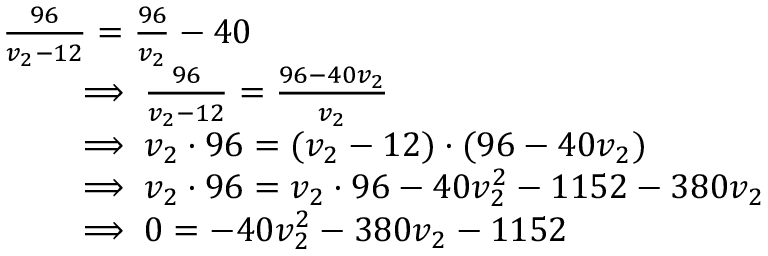Convert formula to latex. <formula><loc_0><loc_0><loc_500><loc_500>\begin{array} { r l } & { \frac { 9 6 } { v _ { 2 } - 1 2 } = \frac { 9 6 } { v _ { 2 } } - 4 0 } \\ & { \quad \implies \frac { 9 6 } { v _ { 2 } - 1 2 } = \frac { 9 6 - 4 0 v _ { 2 } } { v _ { 2 } } } \\ & { \quad \implies v _ { 2 } \cdot 9 6 = ( v _ { 2 } - 1 2 ) \cdot ( 9 6 - 4 0 v _ { 2 } ) } \\ & { \quad \implies v _ { 2 } \cdot 9 6 = v _ { 2 } \cdot 9 6 - 4 0 v _ { 2 } ^ { 2 } - 1 1 5 2 - 3 8 0 v _ { 2 } } \\ & { \quad \implies 0 = - 4 0 v _ { 2 } ^ { 2 } - 3 8 0 v _ { 2 } - 1 1 5 2 } \end{array}</formula> 